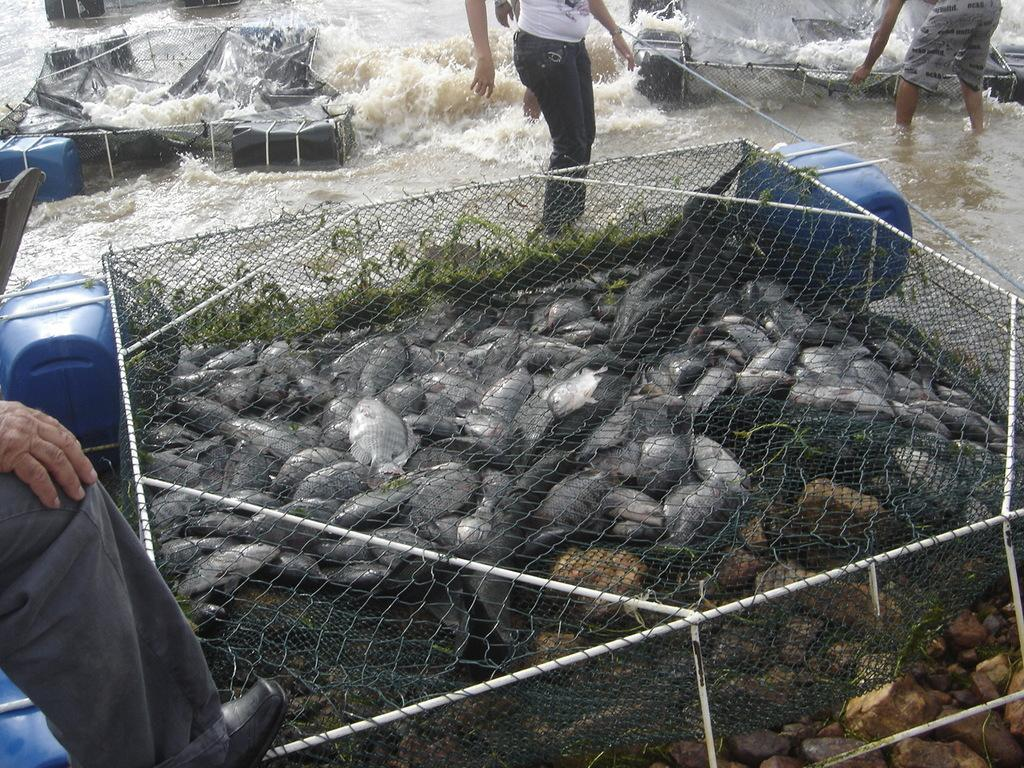What can be seen through the mesh in the image? There are fishes visible through the mesh. Who or what else is present in the image? There are people in the image. What is the primary element in the image? There is water in the image. Can you describe the objects and things in the image? There are objects and things in the image, but their specific nature is not mentioned in the provided facts. How many ladybugs can be seen in the image? There is no mention of ladybugs in the provided facts, so we cannot determine their presence or quantity in the image. 